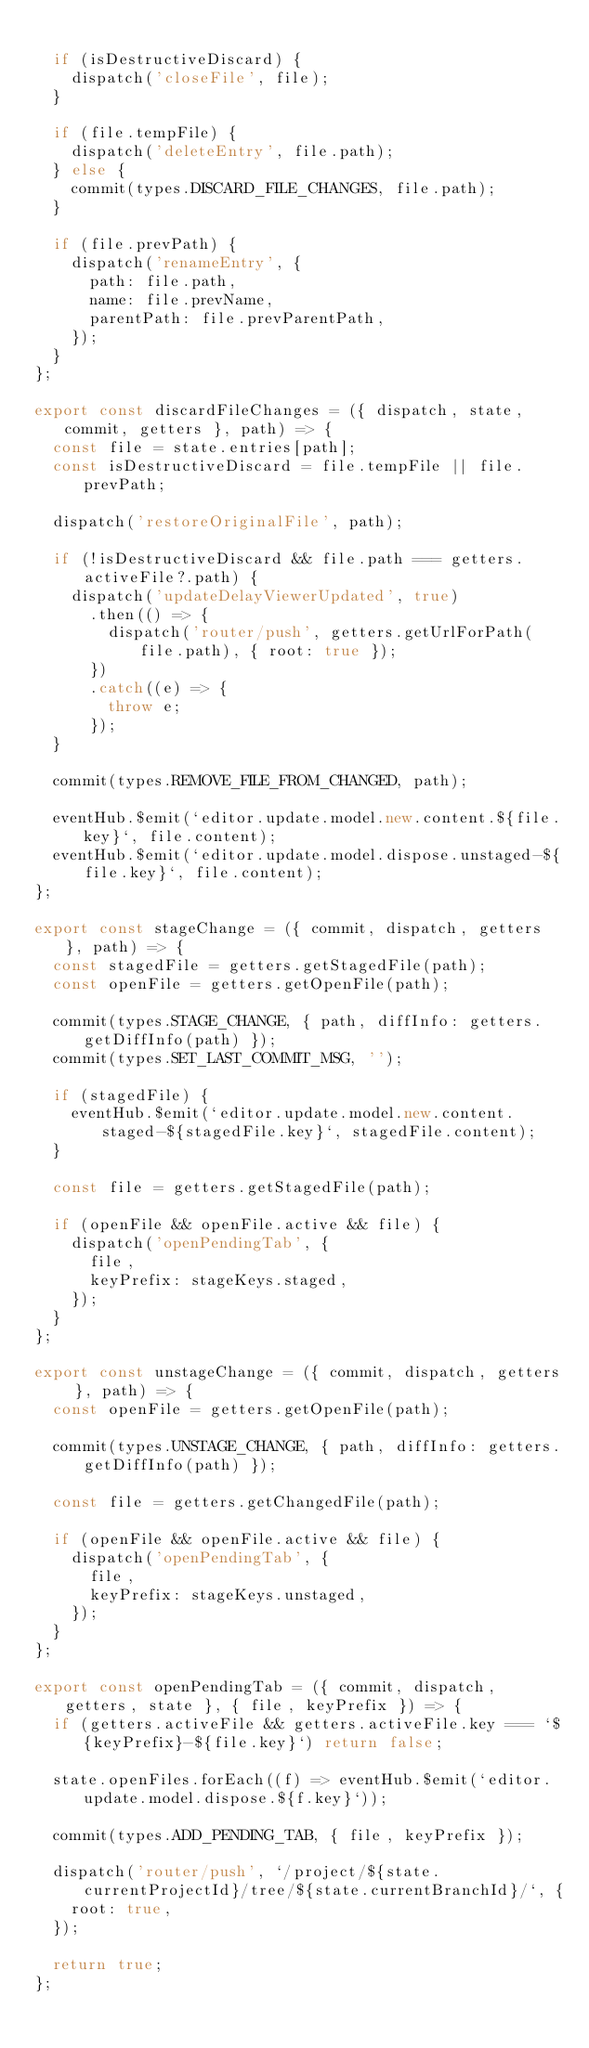<code> <loc_0><loc_0><loc_500><loc_500><_JavaScript_>
  if (isDestructiveDiscard) {
    dispatch('closeFile', file);
  }

  if (file.tempFile) {
    dispatch('deleteEntry', file.path);
  } else {
    commit(types.DISCARD_FILE_CHANGES, file.path);
  }

  if (file.prevPath) {
    dispatch('renameEntry', {
      path: file.path,
      name: file.prevName,
      parentPath: file.prevParentPath,
    });
  }
};

export const discardFileChanges = ({ dispatch, state, commit, getters }, path) => {
  const file = state.entries[path];
  const isDestructiveDiscard = file.tempFile || file.prevPath;

  dispatch('restoreOriginalFile', path);

  if (!isDestructiveDiscard && file.path === getters.activeFile?.path) {
    dispatch('updateDelayViewerUpdated', true)
      .then(() => {
        dispatch('router/push', getters.getUrlForPath(file.path), { root: true });
      })
      .catch((e) => {
        throw e;
      });
  }

  commit(types.REMOVE_FILE_FROM_CHANGED, path);

  eventHub.$emit(`editor.update.model.new.content.${file.key}`, file.content);
  eventHub.$emit(`editor.update.model.dispose.unstaged-${file.key}`, file.content);
};

export const stageChange = ({ commit, dispatch, getters }, path) => {
  const stagedFile = getters.getStagedFile(path);
  const openFile = getters.getOpenFile(path);

  commit(types.STAGE_CHANGE, { path, diffInfo: getters.getDiffInfo(path) });
  commit(types.SET_LAST_COMMIT_MSG, '');

  if (stagedFile) {
    eventHub.$emit(`editor.update.model.new.content.staged-${stagedFile.key}`, stagedFile.content);
  }

  const file = getters.getStagedFile(path);

  if (openFile && openFile.active && file) {
    dispatch('openPendingTab', {
      file,
      keyPrefix: stageKeys.staged,
    });
  }
};

export const unstageChange = ({ commit, dispatch, getters }, path) => {
  const openFile = getters.getOpenFile(path);

  commit(types.UNSTAGE_CHANGE, { path, diffInfo: getters.getDiffInfo(path) });

  const file = getters.getChangedFile(path);

  if (openFile && openFile.active && file) {
    dispatch('openPendingTab', {
      file,
      keyPrefix: stageKeys.unstaged,
    });
  }
};

export const openPendingTab = ({ commit, dispatch, getters, state }, { file, keyPrefix }) => {
  if (getters.activeFile && getters.activeFile.key === `${keyPrefix}-${file.key}`) return false;

  state.openFiles.forEach((f) => eventHub.$emit(`editor.update.model.dispose.${f.key}`));

  commit(types.ADD_PENDING_TAB, { file, keyPrefix });

  dispatch('router/push', `/project/${state.currentProjectId}/tree/${state.currentBranchId}/`, {
    root: true,
  });

  return true;
};
</code> 